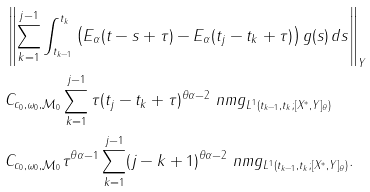<formula> <loc_0><loc_0><loc_500><loc_500>& \left \| \sum _ { k = 1 } ^ { j - 1 } \int _ { t _ { k - 1 } } ^ { t _ { k } } \left ( E _ { \alpha } ( t - s + \tau ) - E _ { \alpha } ( t _ { j } - t _ { k } + \tau ) \right ) g ( s ) \, d s \right \| _ { Y } \\ & C _ { c _ { 0 } , \omega _ { 0 } , \mathcal { M } _ { 0 } } \sum _ { k = 1 } ^ { j - 1 } \tau ( t _ { j } - t _ { k } + \tau ) ^ { \theta \alpha - 2 } \ n m { g } _ { L ^ { 1 } ( t _ { k - 1 } , t _ { k } ; [ X ^ { * } , Y ] _ { \theta } ) } \\ & C _ { c _ { 0 } , \omega _ { 0 } , \mathcal { M } _ { 0 } } \tau ^ { \theta \alpha - 1 } \sum _ { k = 1 } ^ { j - 1 } ( j - k + 1 ) ^ { \theta \alpha - 2 } \ n m { g } _ { L ^ { 1 } ( t _ { k - 1 } , t _ { k } ; [ X ^ { * } , Y ] _ { \theta } ) } .</formula> 